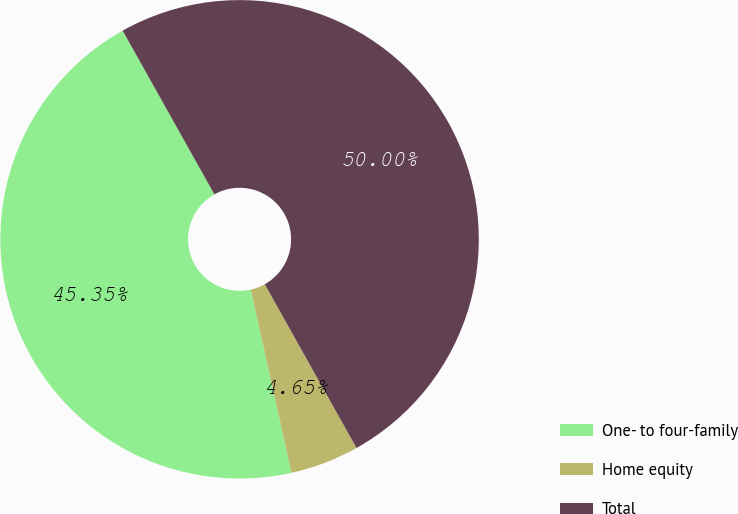Convert chart. <chart><loc_0><loc_0><loc_500><loc_500><pie_chart><fcel>One- to four-family<fcel>Home equity<fcel>Total<nl><fcel>45.35%<fcel>4.65%<fcel>50.0%<nl></chart> 